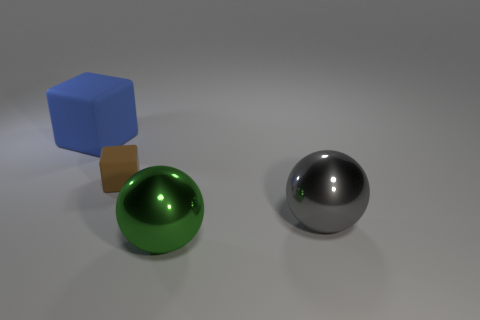Add 2 big purple shiny spheres. How many objects exist? 6 Subtract all brown blocks. How many blocks are left? 1 Subtract 1 balls. How many balls are left? 1 Subtract all red cubes. How many cyan spheres are left? 0 Subtract all purple spheres. Subtract all cyan cubes. How many spheres are left? 2 Subtract all small brown matte objects. Subtract all big gray balls. How many objects are left? 2 Add 1 spheres. How many spheres are left? 3 Add 4 large gray metal balls. How many large gray metal balls exist? 5 Subtract 0 blue cylinders. How many objects are left? 4 